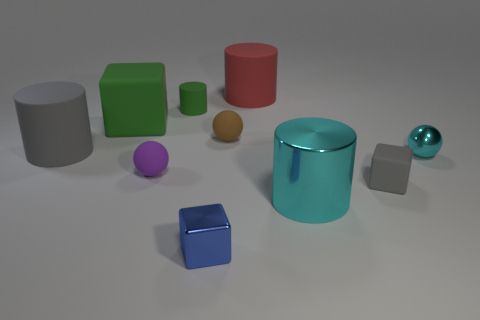Subtract all small cylinders. How many cylinders are left? 3 Subtract all brown spheres. How many spheres are left? 2 Subtract all spheres. How many objects are left? 7 Subtract 2 balls. How many balls are left? 1 Subtract all yellow balls. How many blue cylinders are left? 0 Add 9 big gray cubes. How many big gray cubes exist? 9 Subtract 0 red cubes. How many objects are left? 10 Subtract all brown cylinders. Subtract all purple spheres. How many cylinders are left? 4 Subtract all tiny green metallic blocks. Subtract all green matte cylinders. How many objects are left? 9 Add 7 purple matte things. How many purple matte things are left? 8 